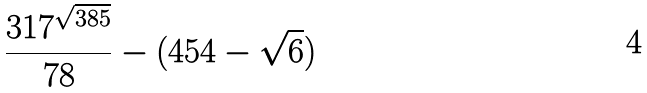Convert formula to latex. <formula><loc_0><loc_0><loc_500><loc_500>\frac { 3 1 7 ^ { \sqrt { 3 8 5 } } } { 7 8 } - ( 4 5 4 - \sqrt { 6 } )</formula> 